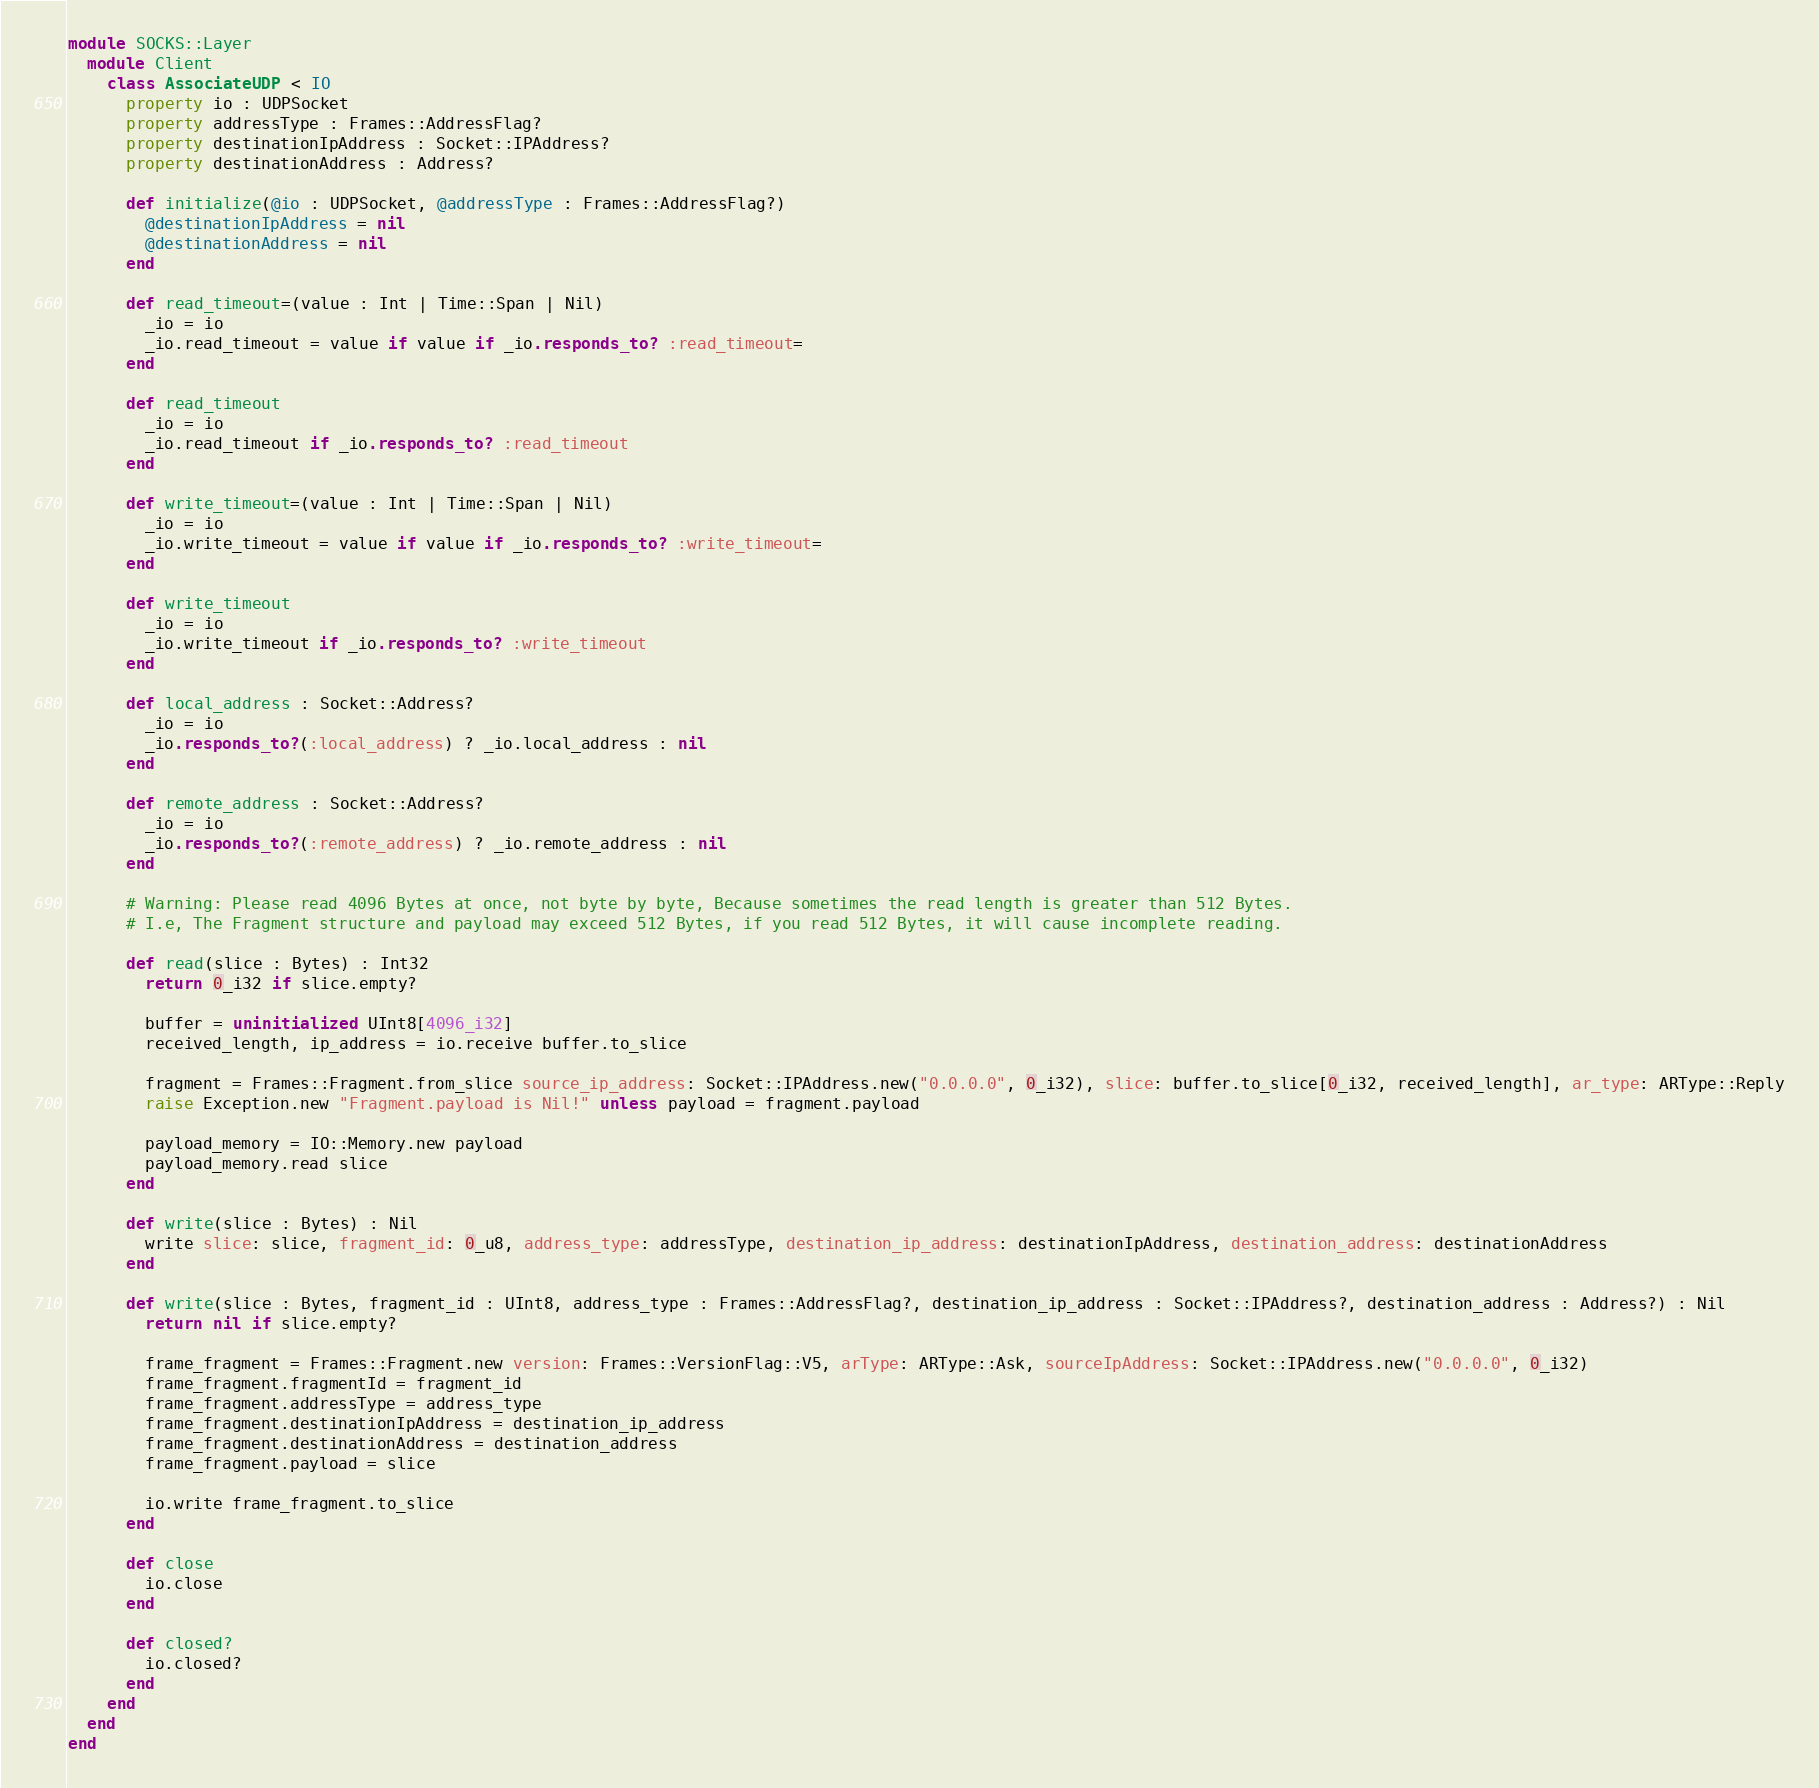Convert code to text. <code><loc_0><loc_0><loc_500><loc_500><_Crystal_>module SOCKS::Layer
  module Client
    class AssociateUDP < IO
      property io : UDPSocket
      property addressType : Frames::AddressFlag?
      property destinationIpAddress : Socket::IPAddress?
      property destinationAddress : Address?

      def initialize(@io : UDPSocket, @addressType : Frames::AddressFlag?)
        @destinationIpAddress = nil
        @destinationAddress = nil
      end

      def read_timeout=(value : Int | Time::Span | Nil)
        _io = io
        _io.read_timeout = value if value if _io.responds_to? :read_timeout=
      end

      def read_timeout
        _io = io
        _io.read_timeout if _io.responds_to? :read_timeout
      end

      def write_timeout=(value : Int | Time::Span | Nil)
        _io = io
        _io.write_timeout = value if value if _io.responds_to? :write_timeout=
      end

      def write_timeout
        _io = io
        _io.write_timeout if _io.responds_to? :write_timeout
      end

      def local_address : Socket::Address?
        _io = io
        _io.responds_to?(:local_address) ? _io.local_address : nil
      end

      def remote_address : Socket::Address?
        _io = io
        _io.responds_to?(:remote_address) ? _io.remote_address : nil
      end

      # Warning: Please read 4096 Bytes at once, not byte by byte, Because sometimes the read length is greater than 512 Bytes.
      # I.e, The Fragment structure and payload may exceed 512 Bytes, if you read 512 Bytes, it will cause incomplete reading.

      def read(slice : Bytes) : Int32
        return 0_i32 if slice.empty?

        buffer = uninitialized UInt8[4096_i32]
        received_length, ip_address = io.receive buffer.to_slice

        fragment = Frames::Fragment.from_slice source_ip_address: Socket::IPAddress.new("0.0.0.0", 0_i32), slice: buffer.to_slice[0_i32, received_length], ar_type: ARType::Reply
        raise Exception.new "Fragment.payload is Nil!" unless payload = fragment.payload

        payload_memory = IO::Memory.new payload
        payload_memory.read slice
      end

      def write(slice : Bytes) : Nil
        write slice: slice, fragment_id: 0_u8, address_type: addressType, destination_ip_address: destinationIpAddress, destination_address: destinationAddress
      end

      def write(slice : Bytes, fragment_id : UInt8, address_type : Frames::AddressFlag?, destination_ip_address : Socket::IPAddress?, destination_address : Address?) : Nil
        return nil if slice.empty?

        frame_fragment = Frames::Fragment.new version: Frames::VersionFlag::V5, arType: ARType::Ask, sourceIpAddress: Socket::IPAddress.new("0.0.0.0", 0_i32)
        frame_fragment.fragmentId = fragment_id
        frame_fragment.addressType = address_type
        frame_fragment.destinationIpAddress = destination_ip_address
        frame_fragment.destinationAddress = destination_address
        frame_fragment.payload = slice

        io.write frame_fragment.to_slice
      end

      def close
        io.close
      end

      def closed?
        io.closed?
      end
    end
  end
end
</code> 